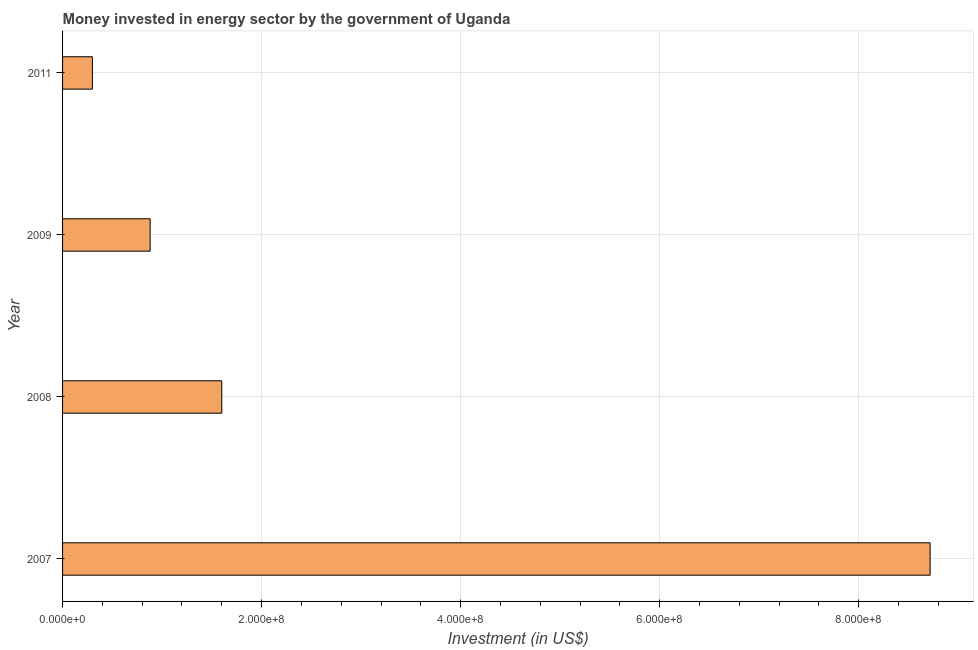Does the graph contain any zero values?
Give a very brief answer. No. Does the graph contain grids?
Keep it short and to the point. Yes. What is the title of the graph?
Ensure brevity in your answer.  Money invested in energy sector by the government of Uganda. What is the label or title of the X-axis?
Give a very brief answer. Investment (in US$). What is the investment in energy in 2008?
Your answer should be compact. 1.60e+08. Across all years, what is the maximum investment in energy?
Keep it short and to the point. 8.72e+08. Across all years, what is the minimum investment in energy?
Provide a short and direct response. 3.00e+07. In which year was the investment in energy minimum?
Give a very brief answer. 2011. What is the sum of the investment in energy?
Your response must be concise. 1.15e+09. What is the difference between the investment in energy in 2009 and 2011?
Your answer should be compact. 5.80e+07. What is the average investment in energy per year?
Give a very brief answer. 2.87e+08. What is the median investment in energy?
Provide a succinct answer. 1.24e+08. In how many years, is the investment in energy greater than 80000000 US$?
Your answer should be very brief. 3. Do a majority of the years between 2011 and 2007 (inclusive) have investment in energy greater than 640000000 US$?
Ensure brevity in your answer.  Yes. What is the ratio of the investment in energy in 2007 to that in 2008?
Provide a succinct answer. 5.45. Is the difference between the investment in energy in 2008 and 2009 greater than the difference between any two years?
Offer a very short reply. No. What is the difference between the highest and the second highest investment in energy?
Keep it short and to the point. 7.12e+08. Is the sum of the investment in energy in 2009 and 2011 greater than the maximum investment in energy across all years?
Provide a short and direct response. No. What is the difference between the highest and the lowest investment in energy?
Offer a terse response. 8.42e+08. How many bars are there?
Keep it short and to the point. 4. What is the difference between two consecutive major ticks on the X-axis?
Make the answer very short. 2.00e+08. What is the Investment (in US$) in 2007?
Offer a terse response. 8.72e+08. What is the Investment (in US$) in 2008?
Your answer should be very brief. 1.60e+08. What is the Investment (in US$) of 2009?
Your answer should be very brief. 8.80e+07. What is the Investment (in US$) of 2011?
Offer a very short reply. 3.00e+07. What is the difference between the Investment (in US$) in 2007 and 2008?
Your answer should be compact. 7.12e+08. What is the difference between the Investment (in US$) in 2007 and 2009?
Ensure brevity in your answer.  7.84e+08. What is the difference between the Investment (in US$) in 2007 and 2011?
Your response must be concise. 8.42e+08. What is the difference between the Investment (in US$) in 2008 and 2009?
Offer a very short reply. 7.20e+07. What is the difference between the Investment (in US$) in 2008 and 2011?
Your response must be concise. 1.30e+08. What is the difference between the Investment (in US$) in 2009 and 2011?
Make the answer very short. 5.80e+07. What is the ratio of the Investment (in US$) in 2007 to that in 2008?
Provide a short and direct response. 5.45. What is the ratio of the Investment (in US$) in 2007 to that in 2009?
Keep it short and to the point. 9.91. What is the ratio of the Investment (in US$) in 2007 to that in 2011?
Provide a short and direct response. 29.06. What is the ratio of the Investment (in US$) in 2008 to that in 2009?
Provide a succinct answer. 1.82. What is the ratio of the Investment (in US$) in 2008 to that in 2011?
Offer a terse response. 5.33. What is the ratio of the Investment (in US$) in 2009 to that in 2011?
Make the answer very short. 2.93. 